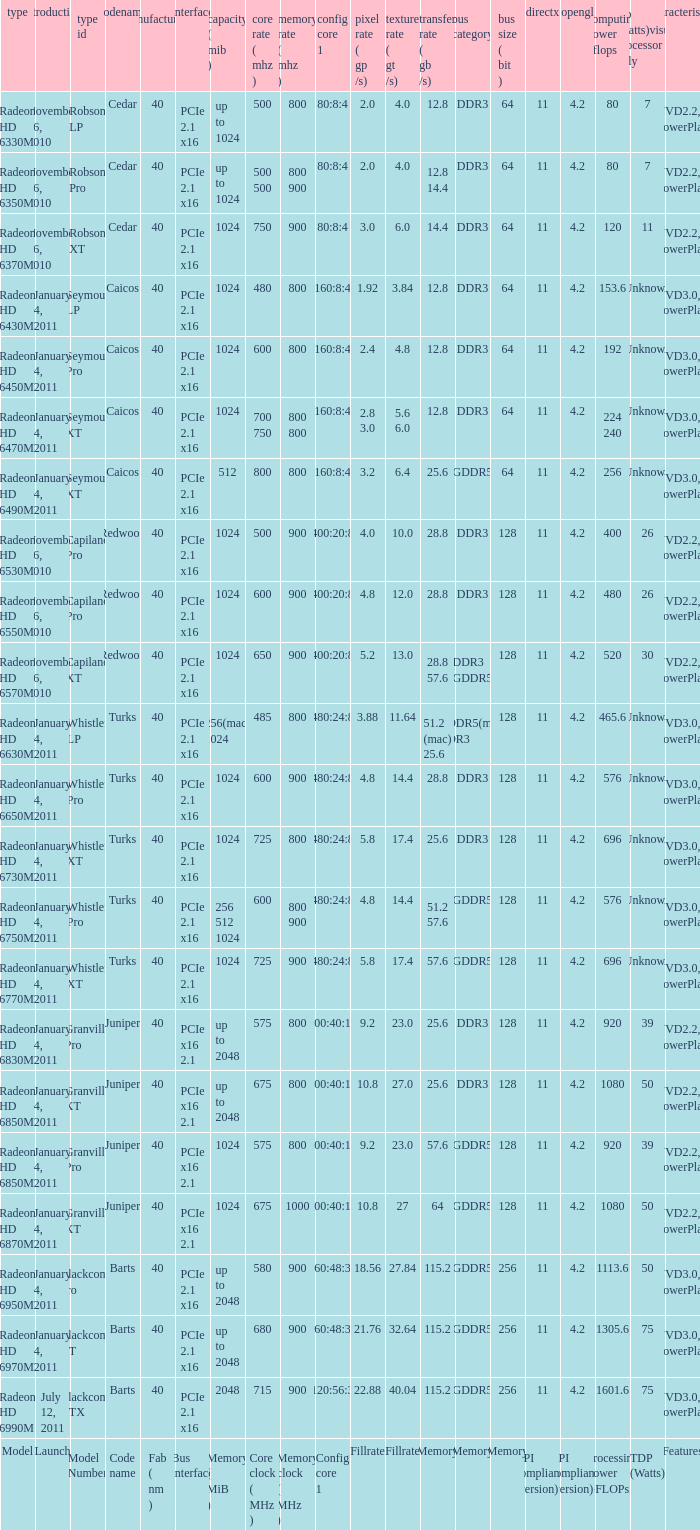Would you be able to parse every entry in this table? {'header': ['type', 'introduction', 'type id', 'codename', 'manufacturing ( nm )', 'interface', 'capacity ( mib )', 'core rate ( mhz )', 'memory rate ( mhz )', 'config core 1', 'pixel rate ( gp /s)', 'texture rate ( gt /s)', 'transfer rate ( gb /s)', 'bus category', 'bus size ( bit )', 'directx', 'opengl', 'computing power gflops', 'tdp (watts)visual processor only', 'characteristics'], 'rows': [['Radeon HD 6330M', 'November 26, 2010', 'Robson LP', 'Cedar', '40', 'PCIe 2.1 x16', 'up to 1024', '500', '800', '80:8:4', '2.0', '4.0', '12.8', 'DDR3', '64', '11', '4.2', '80', '7', 'UVD2.2, PowerPlay'], ['Radeon HD 6350M', 'November 26, 2010', 'Robson Pro', 'Cedar', '40', 'PCIe 2.1 x16', 'up to 1024', '500 500', '800 900', '80:8:4', '2.0', '4.0', '12.8 14.4', 'DDR3', '64', '11', '4.2', '80', '7', 'UVD2.2, PowerPlay'], ['Radeon HD 6370M', 'November 26, 2010', 'Robson XT', 'Cedar', '40', 'PCIe 2.1 x16', '1024', '750', '900', '80:8:4', '3.0', '6.0', '14.4', 'DDR3', '64', '11', '4.2', '120', '11', 'UVD2.2, PowerPlay'], ['Radeon HD 6430M', 'January 4, 2011', 'Seymour LP', 'Caicos', '40', 'PCIe 2.1 x16', '1024', '480', '800', '160:8:4', '1.92', '3.84', '12.8', 'DDR3', '64', '11', '4.2', '153.6', 'Unknown', 'UVD3.0, PowerPlay'], ['Radeon HD 6450M', 'January 4, 2011', 'Seymour Pro', 'Caicos', '40', 'PCIe 2.1 x16', '1024', '600', '800', '160:8:4', '2.4', '4.8', '12.8', 'DDR3', '64', '11', '4.2', '192', 'Unknown', 'UVD3.0, PowerPlay'], ['Radeon HD 6470M', 'January 4, 2011', 'Seymour XT', 'Caicos', '40', 'PCIe 2.1 x16', '1024', '700 750', '800 800', '160:8:4', '2.8 3.0', '5.6 6.0', '12.8', 'DDR3', '64', '11', '4.2', '224 240', 'Unknown', 'UVD3.0, PowerPlay'], ['Radeon HD 6490M', 'January 4, 2011', 'Seymour XT', 'Caicos', '40', 'PCIe 2.1 x16', '512', '800', '800', '160:8:4', '3.2', '6.4', '25.6', 'GDDR5', '64', '11', '4.2', '256', 'Unknown', 'UVD3.0, PowerPlay'], ['Radeon HD 6530M', 'November 26, 2010', 'Capilano Pro', 'Redwood', '40', 'PCIe 2.1 x16', '1024', '500', '900', '400:20:8', '4.0', '10.0', '28.8', 'DDR3', '128', '11', '4.2', '400', '26', 'UVD2.2, PowerPlay'], ['Radeon HD 6550M', 'November 26, 2010', 'Capilano Pro', 'Redwood', '40', 'PCIe 2.1 x16', '1024', '600', '900', '400:20:8', '4.8', '12.0', '28.8', 'DDR3', '128', '11', '4.2', '480', '26', 'UVD2.2, PowerPlay'], ['Radeon HD 6570M', 'November 26, 2010', 'Capilano XT', 'Redwood', '40', 'PCIe 2.1 x16', '1024', '650', '900', '400:20:8', '5.2', '13.0', '28.8 57.6', 'DDR3 GDDR5', '128', '11', '4.2', '520', '30', 'UVD2.2, PowerPlay'], ['Radeon HD 6630M', 'January 4, 2011', 'Whistler LP', 'Turks', '40', 'PCIe 2.1 x16', '256(mac) 1024', '485', '800', '480:24:8', '3.88', '11.64', '51.2 (mac) 25.6', 'GDDR5(mac) DDR3', '128', '11', '4.2', '465.6', 'Unknown', 'UVD3.0, PowerPlay'], ['Radeon HD 6650M', 'January 4, 2011', 'Whistler Pro', 'Turks', '40', 'PCIe 2.1 x16', '1024', '600', '900', '480:24:8', '4.8', '14.4', '28.8', 'DDR3', '128', '11', '4.2', '576', 'Unknown', 'UVD3.0, PowerPlay'], ['Radeon HD 6730M', 'January 4, 2011', 'Whistler XT', 'Turks', '40', 'PCIe 2.1 x16', '1024', '725', '800', '480:24:8', '5.8', '17.4', '25.6', 'DDR3', '128', '11', '4.2', '696', 'Unknown', 'UVD3.0, PowerPlay'], ['Radeon HD 6750M', 'January 4, 2011', 'Whistler Pro', 'Turks', '40', 'PCIe 2.1 x16', '256 512 1024', '600', '800 900', '480:24:8', '4.8', '14.4', '51.2 57.6', 'GDDR5', '128', '11', '4.2', '576', 'Unknown', 'UVD3.0, PowerPlay'], ['Radeon HD 6770M', 'January 4, 2011', 'Whistler XT', 'Turks', '40', 'PCIe 2.1 x16', '1024', '725', '900', '480:24:8', '5.8', '17.4', '57.6', 'GDDR5', '128', '11', '4.2', '696', 'Unknown', 'UVD3.0, PowerPlay'], ['Radeon HD 6830M', 'January 4, 2011', 'Granville Pro', 'Juniper', '40', 'PCIe x16 2.1', 'up to 2048', '575', '800', '800:40:16', '9.2', '23.0', '25.6', 'DDR3', '128', '11', '4.2', '920', '39', 'UVD2.2, PowerPlay'], ['Radeon HD 6850M', 'January 4, 2011', 'Granville XT', 'Juniper', '40', 'PCIe x16 2.1', 'up to 2048', '675', '800', '800:40:16', '10.8', '27.0', '25.6', 'DDR3', '128', '11', '4.2', '1080', '50', 'UVD2.2, PowerPlay'], ['Radeon HD 6850M', 'January 4, 2011', 'Granville Pro', 'Juniper', '40', 'PCIe x16 2.1', '1024', '575', '800', '800:40:16', '9.2', '23.0', '57.6', 'GDDR5', '128', '11', '4.2', '920', '39', 'UVD2.2, PowerPlay'], ['Radeon HD 6870M', 'January 4, 2011', 'Granville XT', 'Juniper', '40', 'PCIe x16 2.1', '1024', '675', '1000', '800:40:16', '10.8', '27', '64', 'GDDR5', '128', '11', '4.2', '1080', '50', 'UVD2.2, PowerPlay'], ['Radeon HD 6950M', 'January 4, 2011', 'Blackcomb Pro', 'Barts', '40', 'PCIe 2.1 x16', 'up to 2048', '580', '900', '960:48:32', '18.56', '27.84', '115.2', 'GDDR5', '256', '11', '4.2', '1113.6', '50', 'UVD3.0, PowerPlay'], ['Radeon HD 6970M', 'January 4, 2011', 'Blackcomb XT', 'Barts', '40', 'PCIe 2.1 x16', 'up to 2048', '680', '900', '960:48:32', '21.76', '32.64', '115.2', 'GDDR5', '256', '11', '4.2', '1305.6', '75', 'UVD3.0, PowerPlay'], ['Radeon HD 6990M', 'July 12, 2011', 'Blackcomb XTX', 'Barts', '40', 'PCIe 2.1 x16', '2048', '715', '900', '1120:56:32', '22.88', '40.04', '115.2', 'GDDR5', '256', '11', '4.2', '1601.6', '75', 'UVD3.0, PowerPlay'], ['Model', 'Launch', 'Model Number', 'Code name', 'Fab ( nm )', 'Bus interface', 'Memory ( MiB )', 'Core clock ( MHz )', 'Memory clock ( MHz )', 'Config core 1', 'Fillrate', 'Fillrate', 'Memory', 'Memory', 'Memory', 'API compliance (version)', 'API compliance (version)', 'Processing Power GFLOPs', 'TDP (Watts)', 'Features']]} How many values for fab(nm) if the model number is whistler lp? 1.0. 